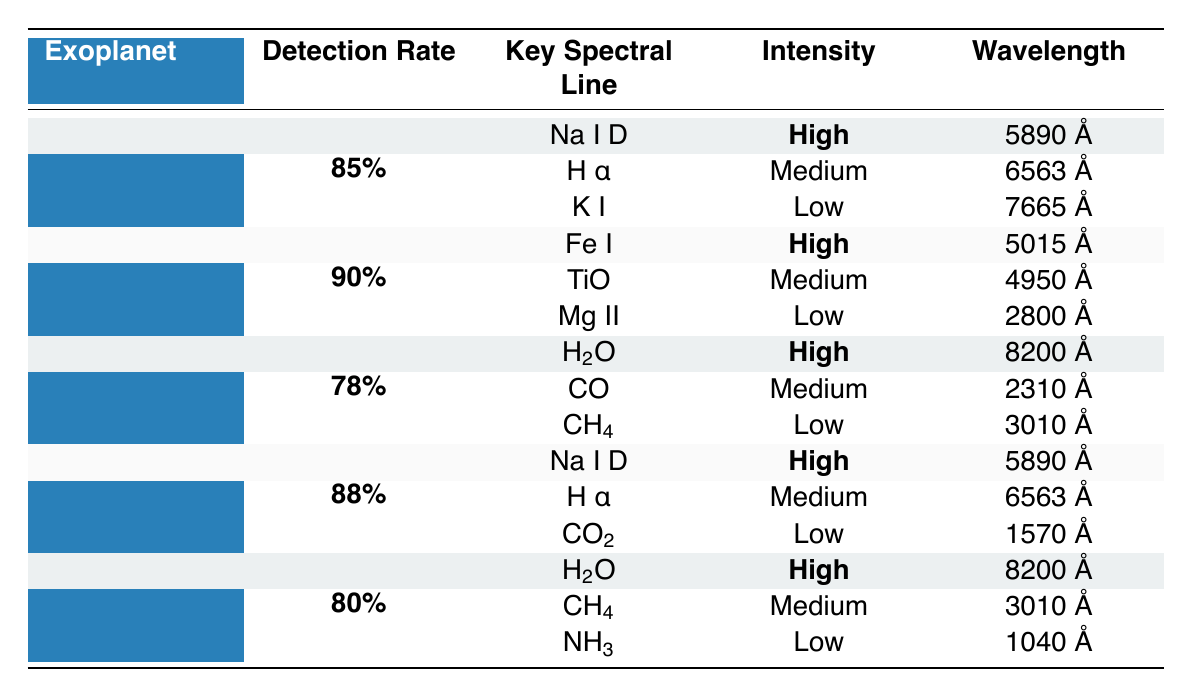What is the detection rate for WASP-12 b? The table shows the row for WASP-12 b, which has a detection rate listed as **90%**.
Answer: 90% Which exoplanet has the highest detection rate? By comparing the detection rates in the table, WASP-12 b has a detection rate of **90%**, which is the highest among all the listed exoplanets.
Answer: WASP-12 b How many exoplanets have a detection rate lower than 85%? The table lists K2-18 b and TRAPPIST-1 e with detection rates of **78%** and **80%**, respectively, which are lower than 85%. Therefore, there are **2** exoplanets.
Answer: 2 Is Na I D detected in both HD 209458 b and GJ 1214 b? Yes, both HD 209458 b and GJ 1214 b have Na I D listed as a detected spectral line in their respective rows.
Answer: Yes What is the average detection rate of the exoplanets listed in the table? The detection rates are 85%, 90%, 78%, 88%, and 80%. Their sum is 85 + 90 + 78 + 88 + 80 = 421, and there are 5 data points, so the average is 421/5 = 84.2%.
Answer: 84.2% Which spectral line from WASP-12 b has a low intensity and what is its wavelength? In the row for WASP-12 b, the spectral line with low intensity is **Mg II**, and its wavelength is **2800 Å**.
Answer: Mg II, 2800 Å Are any of the exoplanets having H2O detected with high intensity? Yes, both K2-18 b and TRAPPIST-1 e have H2O detected with high intensity as listed in their respective rows.
Answer: Yes How many different observational methods are used for the detected spectral lines across all exoplanets? The table lists two observational methods: **Transmission Spectroscopy** and **Reflection Spectroscopy**. Hence, there are **2** different methods.
Answer: 2 What is the most common intensity level for detected spectral lines across the provided exoplanets? By reviewing the spectral lines for each exoplanet, "High" intensity is found for 5 lines across different exoplanets, making it the most common level.
Answer: High Which wavelength corresponds to the high-intensity H2O detected in K2-18 b? In the row for K2-18 b, the high-intensity H2O is detected at the wavelength of **8200 Å**.
Answer: 8200 Å 